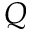Convert formula to latex. <formula><loc_0><loc_0><loc_500><loc_500>Q</formula> 